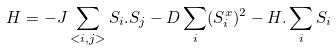Convert formula to latex. <formula><loc_0><loc_0><loc_500><loc_500>H = - J \sum _ { < i , j > } { S } _ { i } . { S } _ { j } - D \sum _ { i } ( S _ { i } ^ { x } ) ^ { 2 } - { H } . \sum _ { i } { S } _ { i }</formula> 